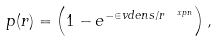Convert formula to latex. <formula><loc_0><loc_0><loc_500><loc_500>p ( r ) = \left ( 1 - e ^ { - \in v d e n s / r ^ { \ x p n } } \right ) ,</formula> 